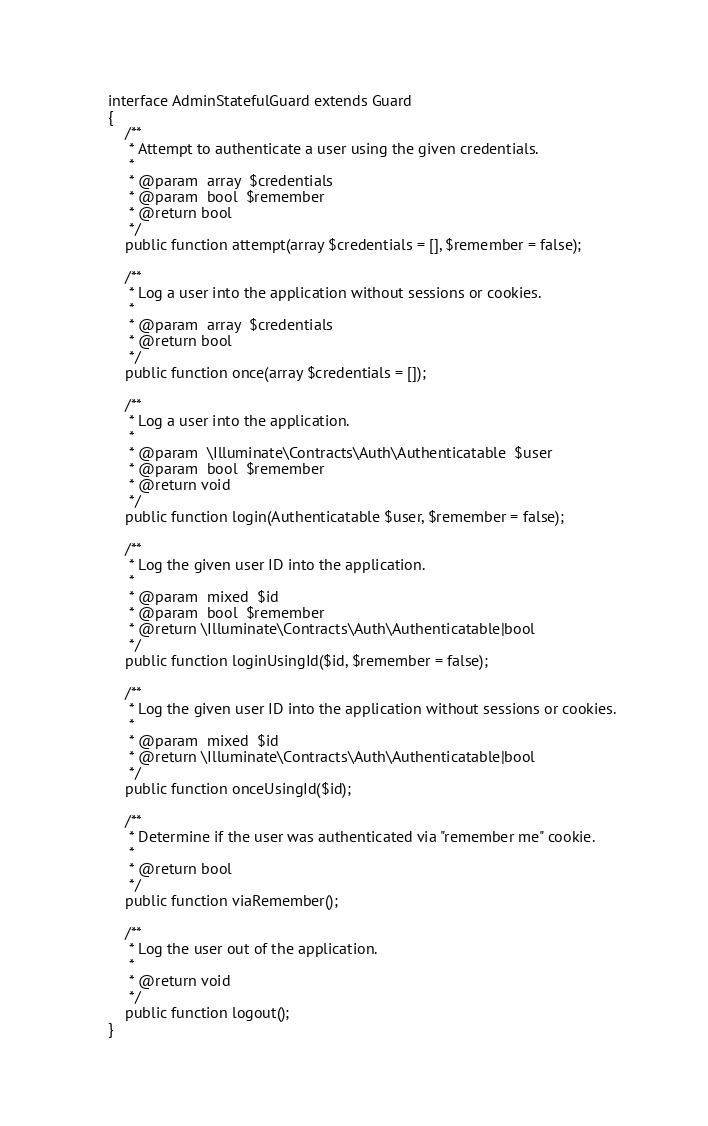<code> <loc_0><loc_0><loc_500><loc_500><_PHP_>
interface AdminStatefulGuard extends Guard
{
    /**
     * Attempt to authenticate a user using the given credentials.
     *
     * @param  array  $credentials
     * @param  bool  $remember
     * @return bool
     */
    public function attempt(array $credentials = [], $remember = false);

    /**
     * Log a user into the application without sessions or cookies.
     *
     * @param  array  $credentials
     * @return bool
     */
    public function once(array $credentials = []);

    /**
     * Log a user into the application.
     *
     * @param  \Illuminate\Contracts\Auth\Authenticatable  $user
     * @param  bool  $remember
     * @return void
     */
    public function login(Authenticatable $user, $remember = false);

    /**
     * Log the given user ID into the application.
     *
     * @param  mixed  $id
     * @param  bool  $remember
     * @return \Illuminate\Contracts\Auth\Authenticatable|bool
     */
    public function loginUsingId($id, $remember = false);

    /**
     * Log the given user ID into the application without sessions or cookies.
     *
     * @param  mixed  $id
     * @return \Illuminate\Contracts\Auth\Authenticatable|bool
     */
    public function onceUsingId($id);

    /**
     * Determine if the user was authenticated via "remember me" cookie.
     *
     * @return bool
     */
    public function viaRemember();

    /**
     * Log the user out of the application.
     *
     * @return void
     */
    public function logout();
}
</code> 